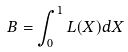Convert formula to latex. <formula><loc_0><loc_0><loc_500><loc_500>B = \int _ { 0 } ^ { 1 } L ( X ) d X</formula> 